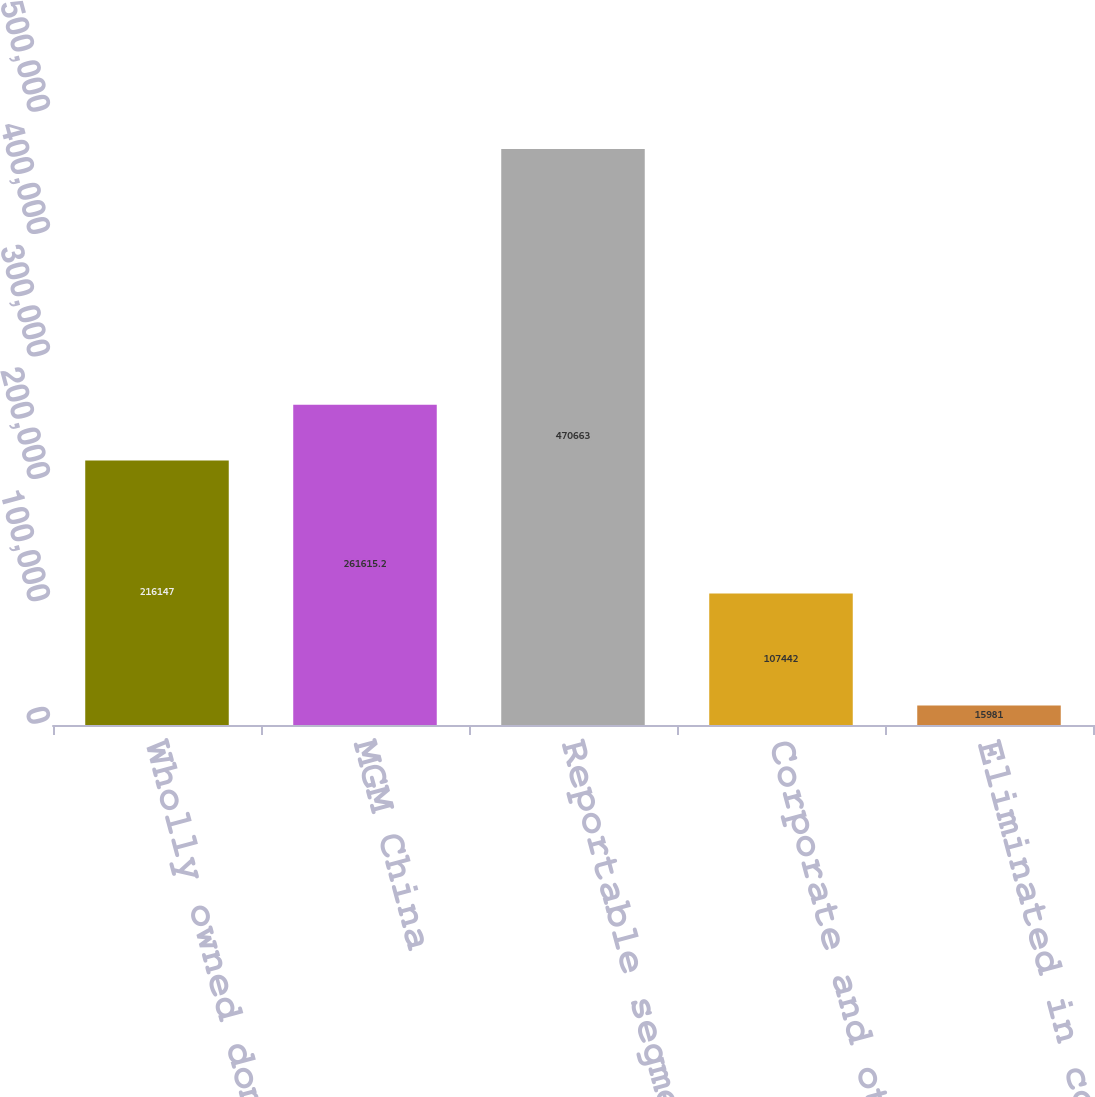Convert chart. <chart><loc_0><loc_0><loc_500><loc_500><bar_chart><fcel>Wholly owned domestic resorts<fcel>MGM China<fcel>Reportable segment capital<fcel>Corporate and other<fcel>Eliminated in consolidation<nl><fcel>216147<fcel>261615<fcel>470663<fcel>107442<fcel>15981<nl></chart> 